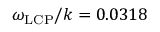<formula> <loc_0><loc_0><loc_500><loc_500>\omega _ { L C P } / k = 0 . 0 3 1 8</formula> 